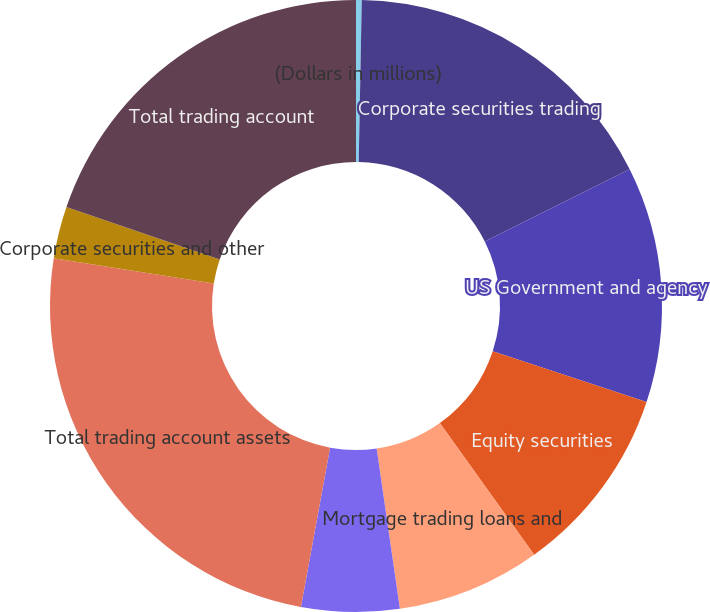Convert chart. <chart><loc_0><loc_0><loc_500><loc_500><pie_chart><fcel>(Dollars in millions)<fcel>Corporate securities trading<fcel>US Government and agency<fcel>Equity securities<fcel>Mortgage trading loans and<fcel>Foreign sovereign debt<fcel>Total trading account assets<fcel>Corporate securities and other<fcel>Total trading account<nl><fcel>0.3%<fcel>17.32%<fcel>12.46%<fcel>10.03%<fcel>7.6%<fcel>5.17%<fcel>24.62%<fcel>2.74%<fcel>19.76%<nl></chart> 